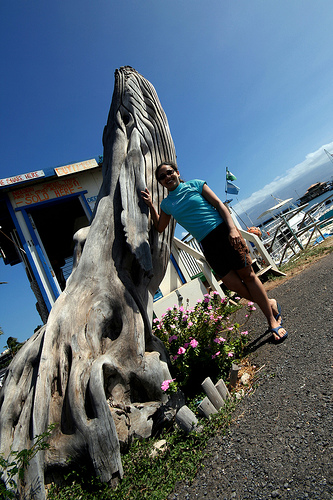<image>
Can you confirm if the plant is under the rock? Yes. The plant is positioned underneath the rock, with the rock above it in the vertical space. Is there a flower next to the plant? Yes. The flower is positioned adjacent to the plant, located nearby in the same general area. 